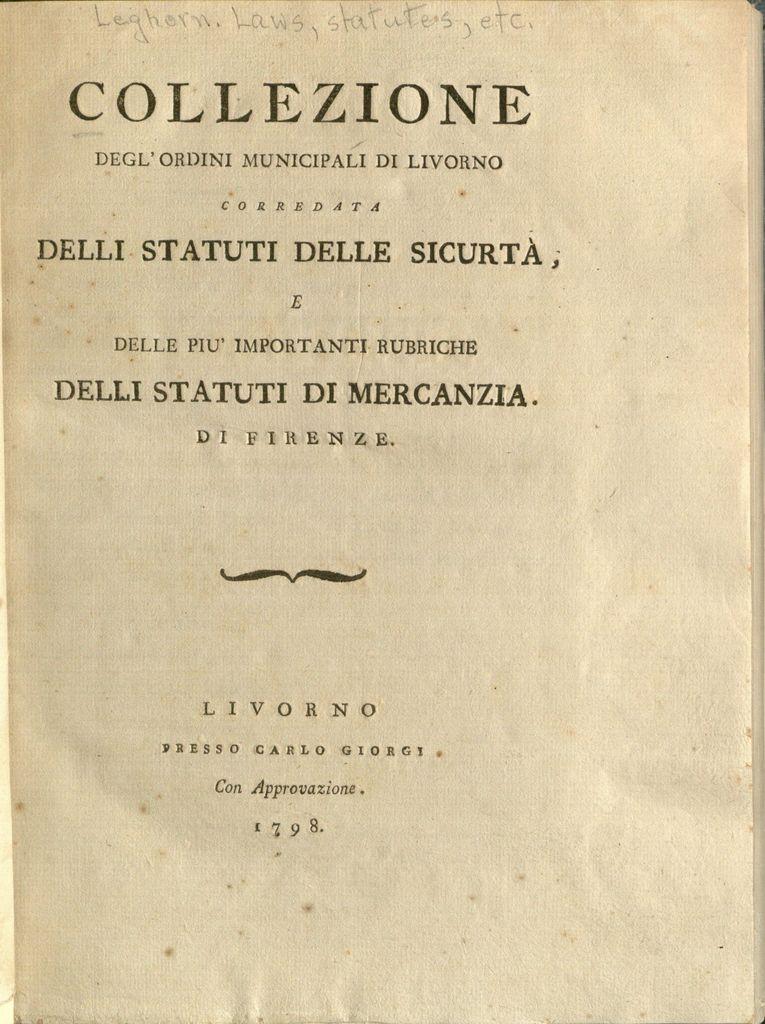What year was this printed in?
Ensure brevity in your answer.  1798. What is the title on the page?
Provide a succinct answer. Collezione. 